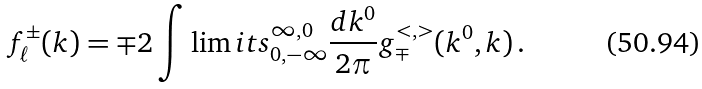<formula> <loc_0><loc_0><loc_500><loc_500>f _ { \ell } ^ { \pm } ( k ) = \mp 2 \int \lim i t s _ { 0 , - \infty } ^ { \infty , 0 } \frac { d k ^ { 0 } } { 2 \pi } g _ { \mp } ^ { < , > } ( k ^ { 0 } , k ) \, .</formula> 